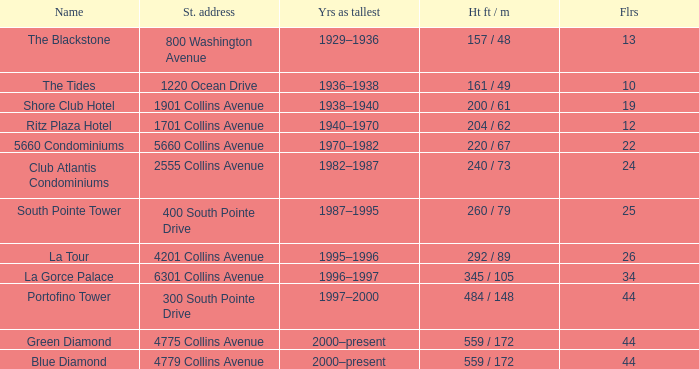How many floors does the Blue Diamond have? 44.0. 